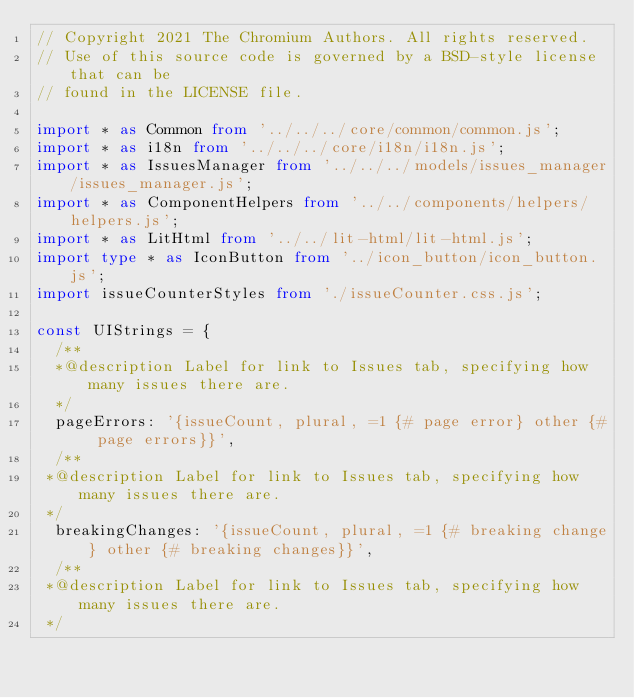Convert code to text. <code><loc_0><loc_0><loc_500><loc_500><_TypeScript_>// Copyright 2021 The Chromium Authors. All rights reserved.
// Use of this source code is governed by a BSD-style license that can be
// found in the LICENSE file.

import * as Common from '../../../core/common/common.js';
import * as i18n from '../../../core/i18n/i18n.js';
import * as IssuesManager from '../../../models/issues_manager/issues_manager.js';
import * as ComponentHelpers from '../../components/helpers/helpers.js';
import * as LitHtml from '../../lit-html/lit-html.js';
import type * as IconButton from '../icon_button/icon_button.js';
import issueCounterStyles from './issueCounter.css.js';

const UIStrings = {
  /**
  *@description Label for link to Issues tab, specifying how many issues there are.
  */
  pageErrors: '{issueCount, plural, =1 {# page error} other {# page errors}}',
  /**
 *@description Label for link to Issues tab, specifying how many issues there are.
 */
  breakingChanges: '{issueCount, plural, =1 {# breaking change} other {# breaking changes}}',
  /**
 *@description Label for link to Issues tab, specifying how many issues there are.
 */</code> 